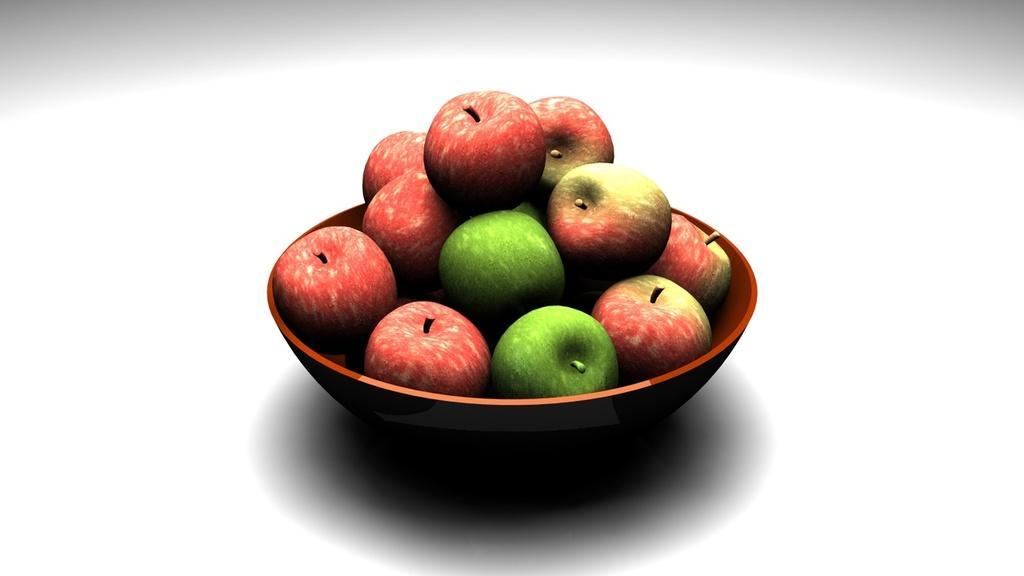Describe this image in one or two sentences. In this image, we can see a bowel, there are some apples kept in the bowl, there is a white background. 